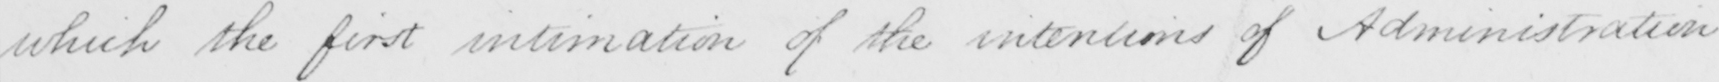What is written in this line of handwriting? which the first intimation of the intentions of Administration 